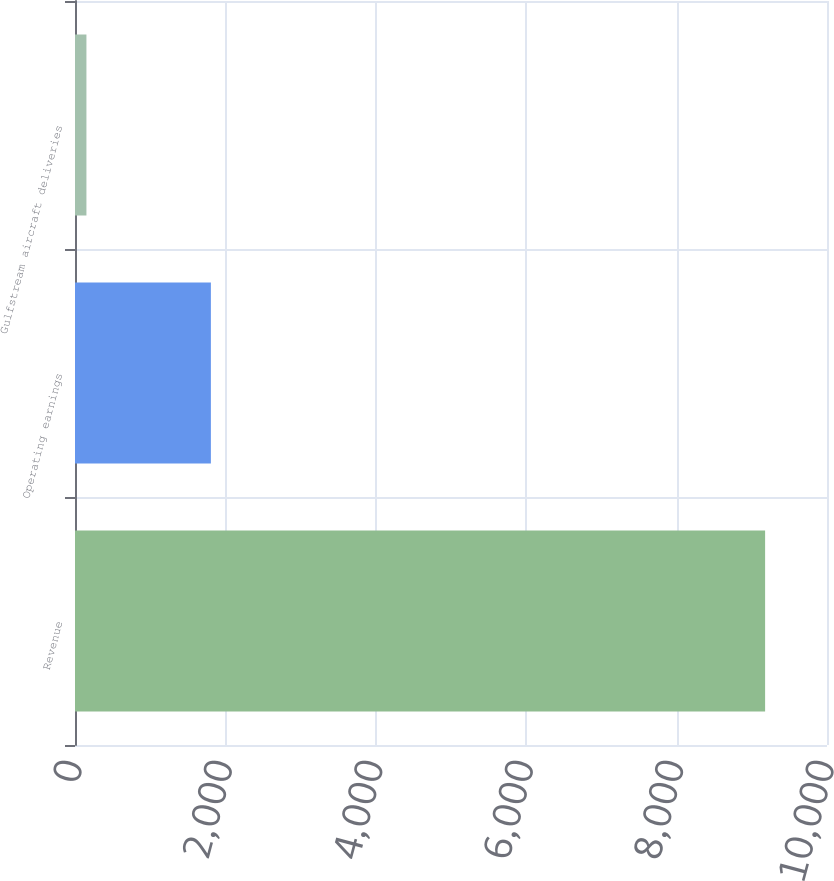Convert chart. <chart><loc_0><loc_0><loc_500><loc_500><bar_chart><fcel>Revenue<fcel>Operating earnings<fcel>Gulfstream aircraft deliveries<nl><fcel>9177<fcel>1807<fcel>152<nl></chart> 